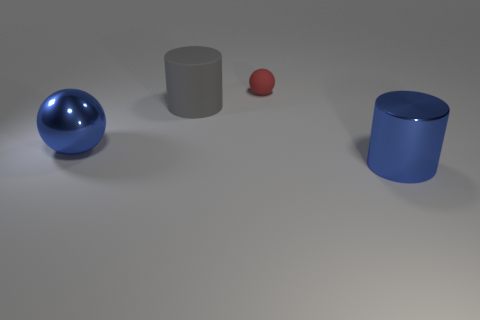Do the objects seem to be interacting in any way? Visually, the objects do not seem to be interacting with each other; they are separate and distinct. There is no overlapping or direct connection, which implies no interaction, just a shared presence within the same space. Their placement does not suggest any narrative or cause-and-effect relationship. 